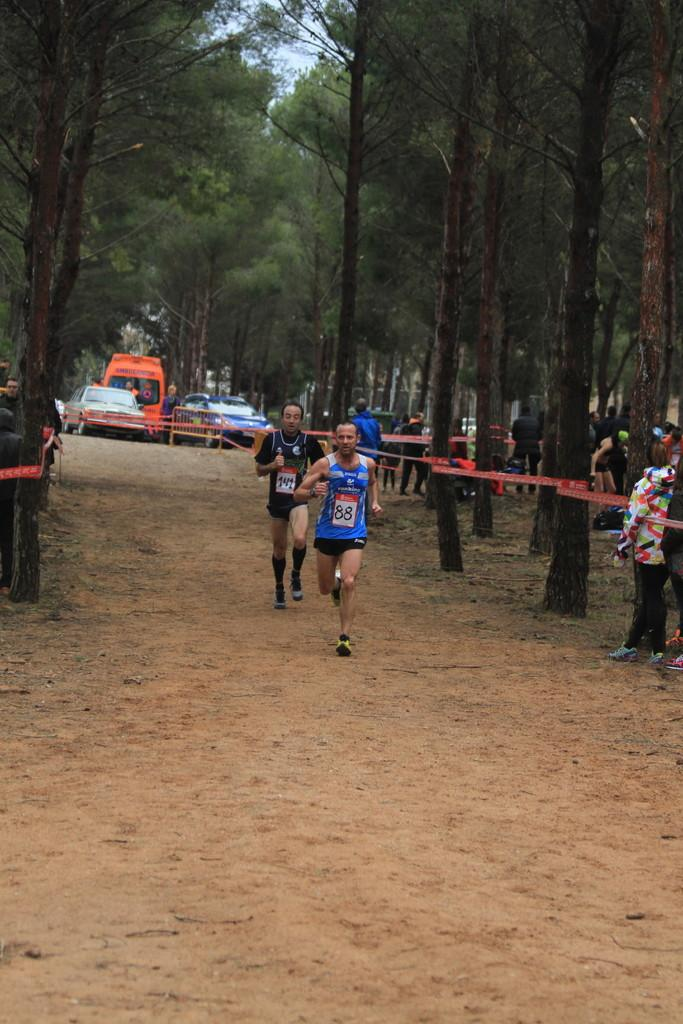What is the dominant feature in the image? There are many trees in the image. What else can be seen in the image besides trees? Some vehicles are parked, there is a fence, many people are standing, some objects are tagged to the trees, and two persons are running in a race. Can you describe the vehicles in the image? The facts provided do not give specific details about the vehicles, so we cannot describe them. What might the objects tagged to the trees be used for? The purpose of the objects tagged to the trees is not mentioned in the facts, so we cannot determine their use. What type of plantation is depicted in the image? There is no plantation present in the image; it features many trees, vehicles, a fence, people, tagged objects, and a race. What knowledge can be gained from studying the system in the image? There is no system mentioned in the image, so we cannot determine what knowledge can be gained from studying it. 